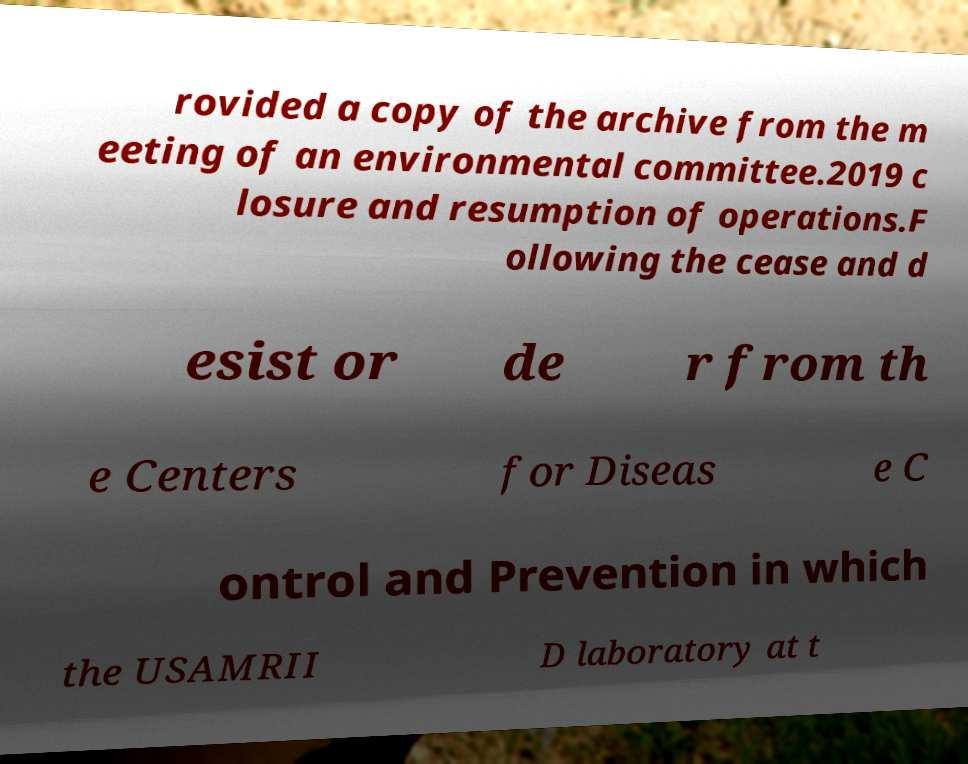There's text embedded in this image that I need extracted. Can you transcribe it verbatim? rovided a copy of the archive from the m eeting of an environmental committee.2019 c losure and resumption of operations.F ollowing the cease and d esist or de r from th e Centers for Diseas e C ontrol and Prevention in which the USAMRII D laboratory at t 